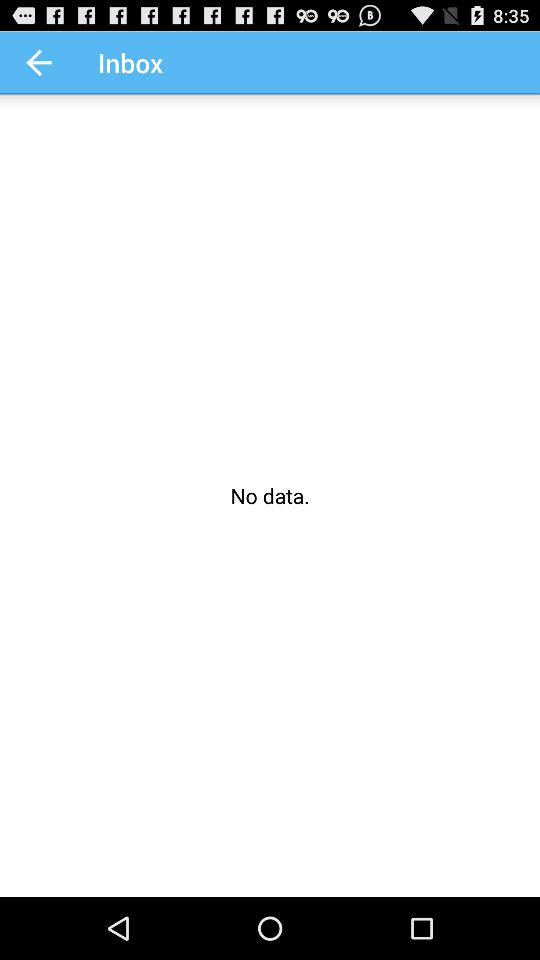How much data is available in the inbox? There is no data in the inbox. 